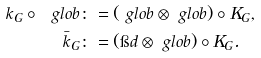Convert formula to latex. <formula><loc_0><loc_0><loc_500><loc_500>k _ { G } \circ \ g l o b & \colon = ( \ g l o b \otimes \ g l o b ) \circ K _ { G } , \\ \bar { k } _ { G } & \colon = ( \i d \otimes \ g l o b ) \circ K _ { G } .</formula> 